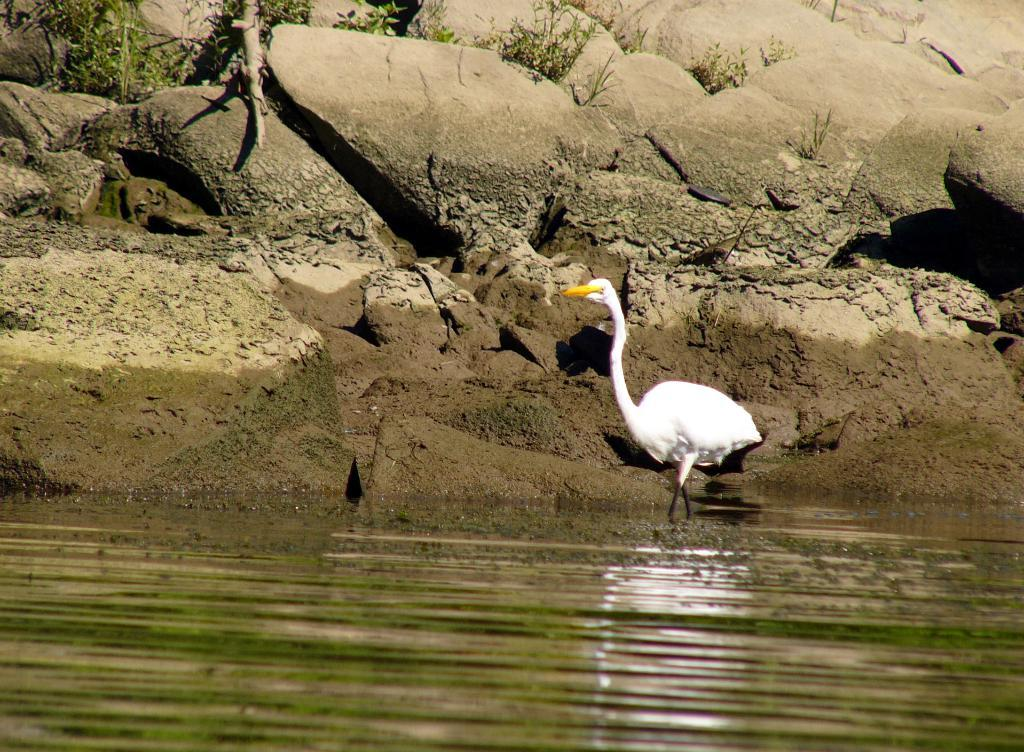What type of animal is in the image? There is a duck in the image. What other objects or features can be seen in the image? There are rocks, plants, water, and a wooden stick visible in the image. What year is the business mentioned in the image? There is no mention of a business or any specific year in the image. 